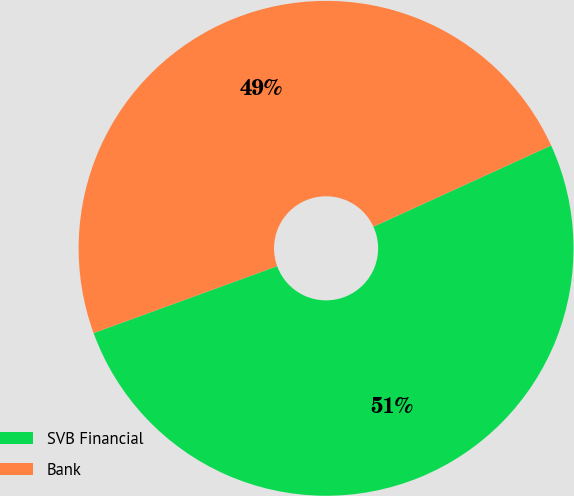<chart> <loc_0><loc_0><loc_500><loc_500><pie_chart><fcel>SVB Financial<fcel>Bank<nl><fcel>51.26%<fcel>48.74%<nl></chart> 